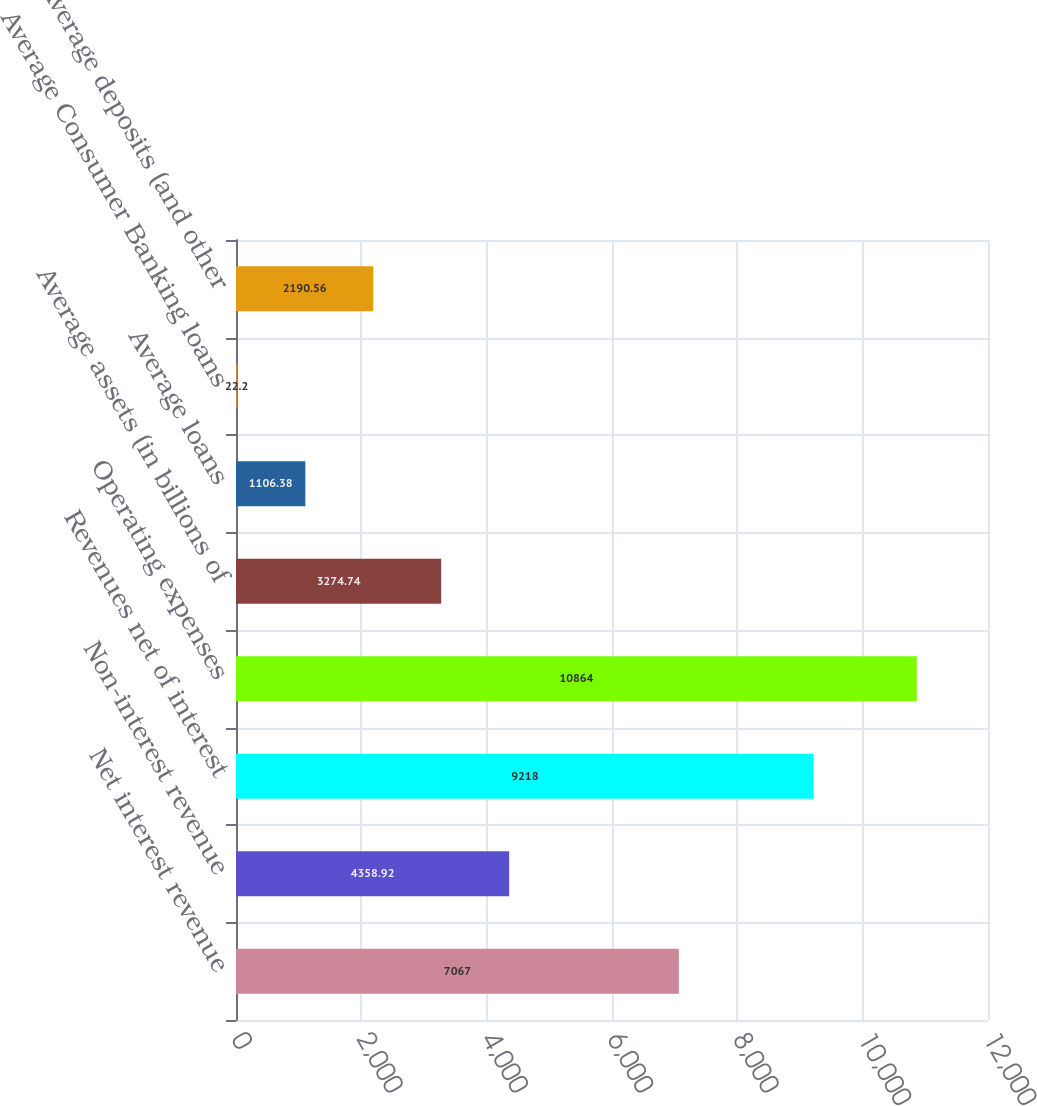Convert chart. <chart><loc_0><loc_0><loc_500><loc_500><bar_chart><fcel>Net interest revenue<fcel>Non-interest revenue<fcel>Revenues net of interest<fcel>Operating expenses<fcel>Average assets (in billions of<fcel>Average loans<fcel>Average Consumer Banking loans<fcel>Average deposits (and other<nl><fcel>7067<fcel>4358.92<fcel>9218<fcel>10864<fcel>3274.74<fcel>1106.38<fcel>22.2<fcel>2190.56<nl></chart> 